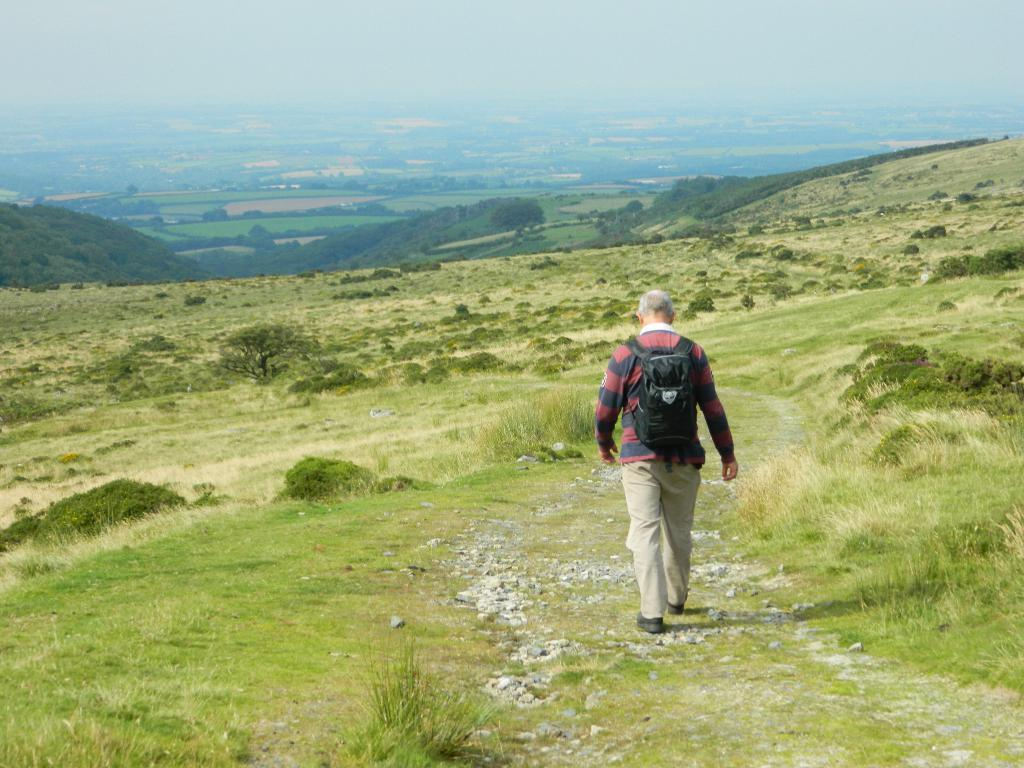What type of vegetation can be seen in the image? There is grass in the image. What else can be found on the ground in the image? There are stones in the image. What is the person in the image doing? There is a person walking in the image. What other natural elements are present in the image? There are trees and mountains in the image. What is the overall setting of the image? The background of the image is full of greenery. What can be seen above the ground in the image? There is a sky visible in the image. What type of oatmeal is being served in the image? There is no oatmeal present in the image. Can you tell me how many brothers are visible in the image? There is no mention of a brother or any other people besides the person walking in the image. 